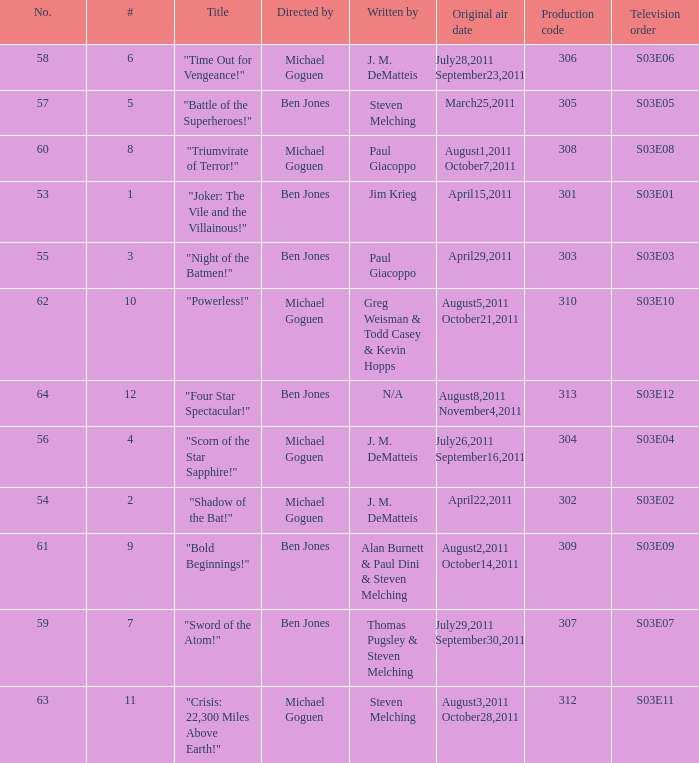Could you parse the entire table? {'header': ['No.', '#', 'Title', 'Directed by', 'Written by', 'Original air date', 'Production code', 'Television order'], 'rows': [['58', '6', '"Time Out for Vengeance!"', 'Michael Goguen', 'J. M. DeMatteis', 'July28,2011 September23,2011', '306', 'S03E06'], ['57', '5', '"Battle of the Superheroes!"', 'Ben Jones', 'Steven Melching', 'March25,2011', '305', 'S03E05'], ['60', '8', '"Triumvirate of Terror!"', 'Michael Goguen', 'Paul Giacoppo', 'August1,2011 October7,2011', '308', 'S03E08'], ['53', '1', '"Joker: The Vile and the Villainous!"', 'Ben Jones', 'Jim Krieg', 'April15,2011', '301', 'S03E01'], ['55', '3', '"Night of the Batmen!"', 'Ben Jones', 'Paul Giacoppo', 'April29,2011', '303', 'S03E03'], ['62', '10', '"Powerless!"', 'Michael Goguen', 'Greg Weisman & Todd Casey & Kevin Hopps', 'August5,2011 October21,2011', '310', 'S03E10'], ['64', '12', '"Four Star Spectacular!"', 'Ben Jones', 'N/A', 'August8,2011 November4,2011', '313', 'S03E12'], ['56', '4', '"Scorn of the Star Sapphire!"', 'Michael Goguen', 'J. M. DeMatteis', 'July26,2011 September16,2011', '304', 'S03E04'], ['54', '2', '"Shadow of the Bat!"', 'Michael Goguen', 'J. M. DeMatteis', 'April22,2011', '302', 'S03E02'], ['61', '9', '"Bold Beginnings!"', 'Ben Jones', 'Alan Burnett & Paul Dini & Steven Melching', 'August2,2011 October14,2011', '309', 'S03E09'], ['59', '7', '"Sword of the Atom!"', 'Ben Jones', 'Thomas Pugsley & Steven Melching', 'July29,2011 September30,2011', '307', 'S03E07'], ['63', '11', '"Crisis: 22,300 Miles Above Earth!"', 'Michael Goguen', 'Steven Melching', 'August3,2011 October28,2011', '312', 'S03E11']]} What is the original air date of the episode directed by ben jones and written by steven melching?  March25,2011. 